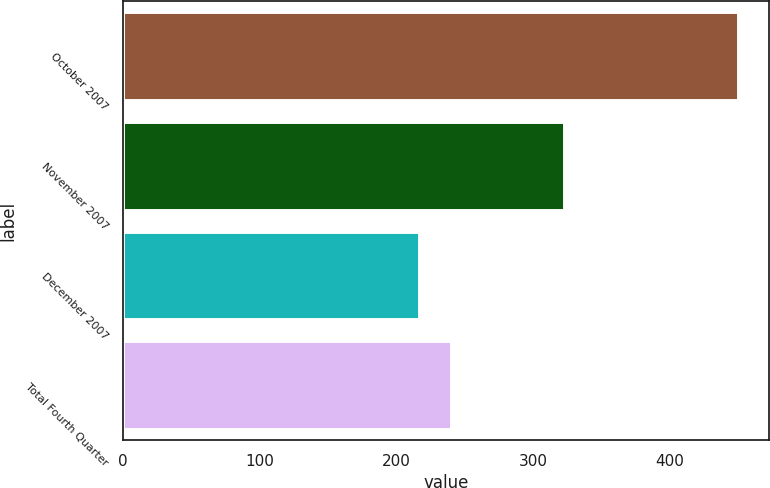Convert chart. <chart><loc_0><loc_0><loc_500><loc_500><bar_chart><fcel>October 2007<fcel>November 2007<fcel>December 2007<fcel>Total Fourth Quarter<nl><fcel>449.9<fcel>322.2<fcel>216.2<fcel>239.57<nl></chart> 